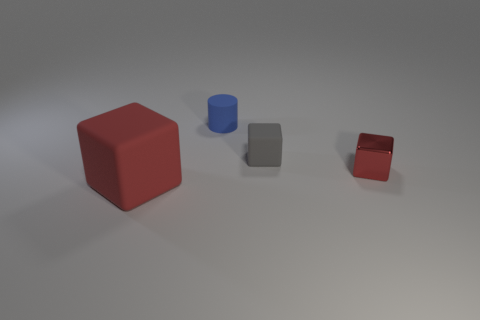Subtract all small gray rubber blocks. How many blocks are left? 2 Add 1 tiny green cubes. How many objects exist? 5 Subtract all gray blocks. How many blocks are left? 2 Subtract 3 cubes. How many cubes are left? 0 Subtract all cylinders. How many objects are left? 3 Subtract 0 cyan blocks. How many objects are left? 4 Subtract all green cylinders. Subtract all purple spheres. How many cylinders are left? 1 Subtract all cyan cylinders. How many red cubes are left? 2 Subtract all big cubes. Subtract all cyan spheres. How many objects are left? 3 Add 2 small matte objects. How many small matte objects are left? 4 